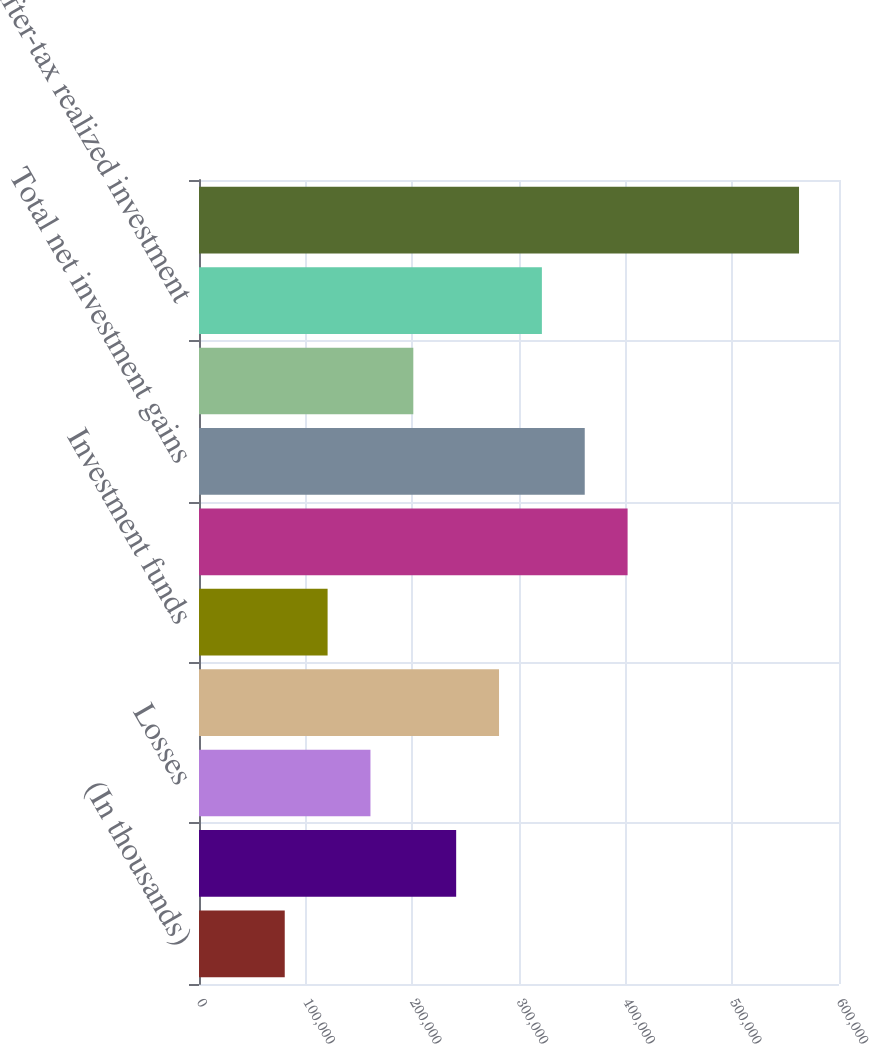Convert chart to OTSL. <chart><loc_0><loc_0><loc_500><loc_500><bar_chart><fcel>(In thousands)<fcel>Gains<fcel>Losses<fcel>Equity securities available<fcel>Investment funds<fcel>Net realized gains on<fcel>Total net investment gains<fcel>Income tax expense<fcel>After-tax realized investment<fcel>Fixed maturity securities<nl><fcel>80384.8<fcel>241098<fcel>160742<fcel>281277<fcel>120563<fcel>401812<fcel>361634<fcel>200920<fcel>321455<fcel>562526<nl></chart> 